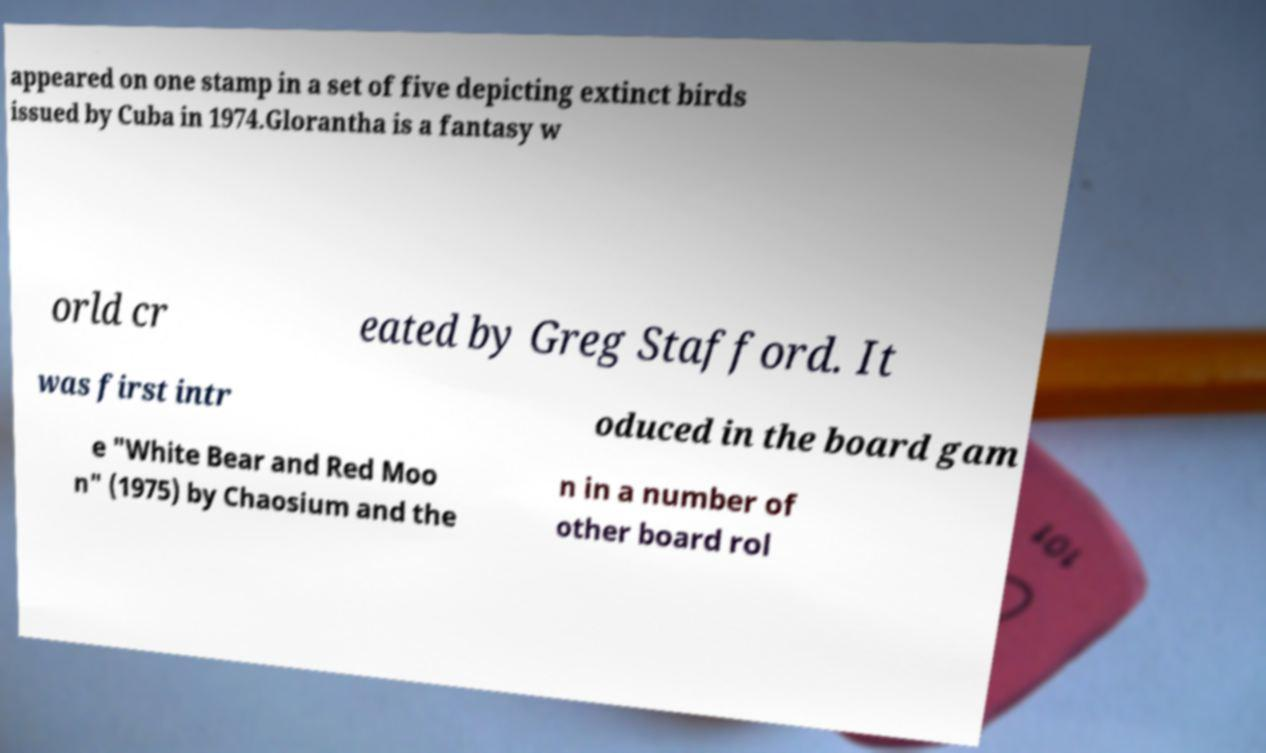For documentation purposes, I need the text within this image transcribed. Could you provide that? appeared on one stamp in a set of five depicting extinct birds issued by Cuba in 1974.Glorantha is a fantasy w orld cr eated by Greg Stafford. It was first intr oduced in the board gam e "White Bear and Red Moo n" (1975) by Chaosium and the n in a number of other board rol 